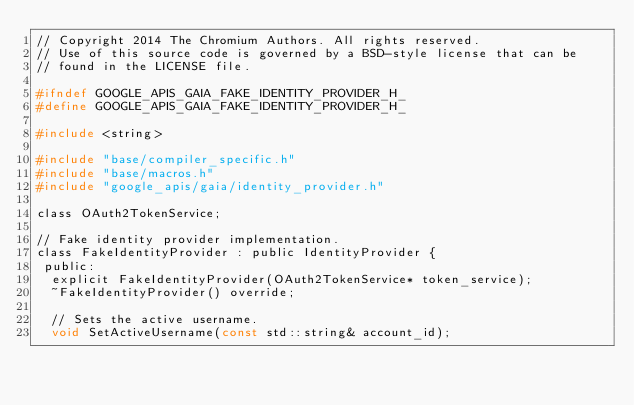Convert code to text. <code><loc_0><loc_0><loc_500><loc_500><_C_>// Copyright 2014 The Chromium Authors. All rights reserved.
// Use of this source code is governed by a BSD-style license that can be
// found in the LICENSE file.

#ifndef GOOGLE_APIS_GAIA_FAKE_IDENTITY_PROVIDER_H_
#define GOOGLE_APIS_GAIA_FAKE_IDENTITY_PROVIDER_H_

#include <string>

#include "base/compiler_specific.h"
#include "base/macros.h"
#include "google_apis/gaia/identity_provider.h"

class OAuth2TokenService;

// Fake identity provider implementation.
class FakeIdentityProvider : public IdentityProvider {
 public:
  explicit FakeIdentityProvider(OAuth2TokenService* token_service);
  ~FakeIdentityProvider() override;

  // Sets the active username.
  void SetActiveUsername(const std::string& account_id);
</code> 